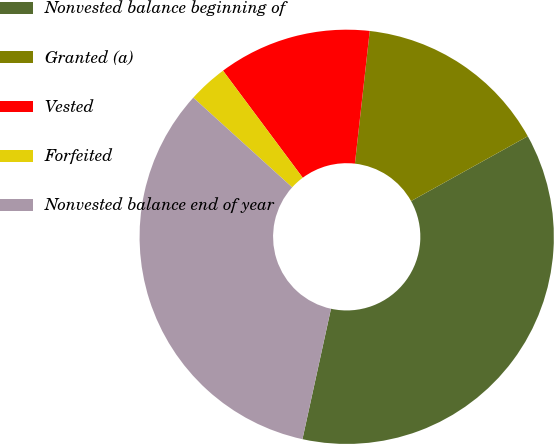Convert chart to OTSL. <chart><loc_0><loc_0><loc_500><loc_500><pie_chart><fcel>Nonvested balance beginning of<fcel>Granted (a)<fcel>Vested<fcel>Forfeited<fcel>Nonvested balance end of year<nl><fcel>36.5%<fcel>15.16%<fcel>11.96%<fcel>3.09%<fcel>33.3%<nl></chart> 